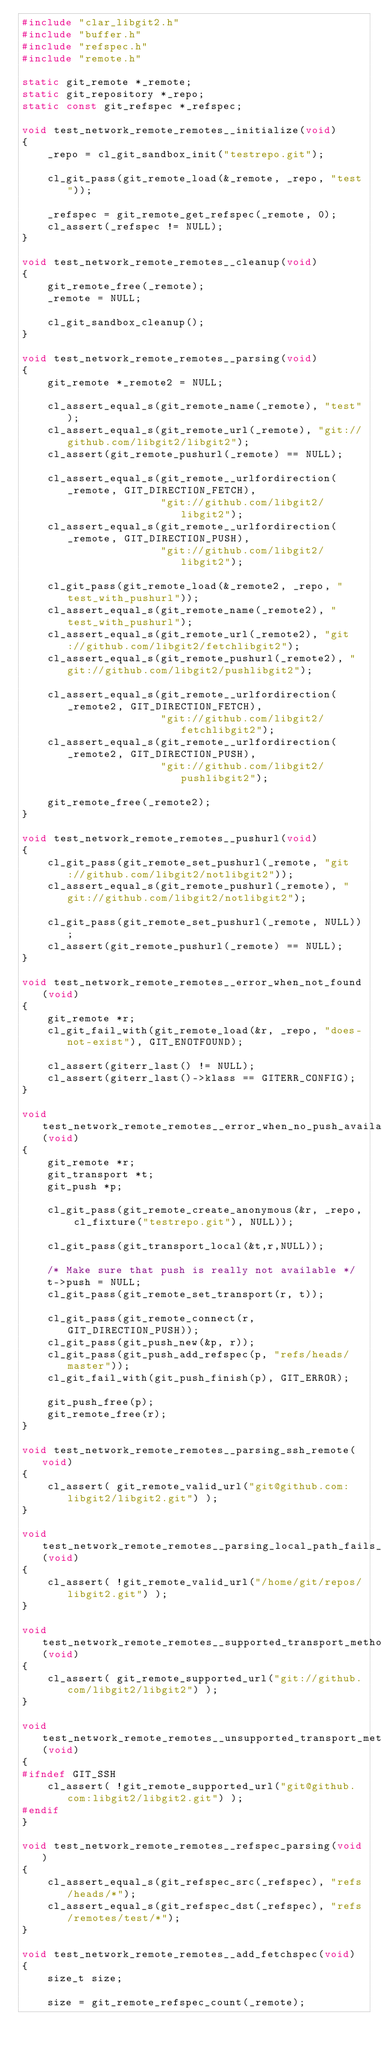Convert code to text. <code><loc_0><loc_0><loc_500><loc_500><_C_>#include "clar_libgit2.h"
#include "buffer.h"
#include "refspec.h"
#include "remote.h"

static git_remote *_remote;
static git_repository *_repo;
static const git_refspec *_refspec;

void test_network_remote_remotes__initialize(void)
{
	_repo = cl_git_sandbox_init("testrepo.git");

	cl_git_pass(git_remote_load(&_remote, _repo, "test"));

	_refspec = git_remote_get_refspec(_remote, 0);
	cl_assert(_refspec != NULL);
}

void test_network_remote_remotes__cleanup(void)
{
	git_remote_free(_remote);
	_remote = NULL;

	cl_git_sandbox_cleanup();
}

void test_network_remote_remotes__parsing(void)
{
	git_remote *_remote2 = NULL;

	cl_assert_equal_s(git_remote_name(_remote), "test");
	cl_assert_equal_s(git_remote_url(_remote), "git://github.com/libgit2/libgit2");
	cl_assert(git_remote_pushurl(_remote) == NULL);

	cl_assert_equal_s(git_remote__urlfordirection(_remote, GIT_DIRECTION_FETCH),
					  "git://github.com/libgit2/libgit2");
	cl_assert_equal_s(git_remote__urlfordirection(_remote, GIT_DIRECTION_PUSH),
					  "git://github.com/libgit2/libgit2");

	cl_git_pass(git_remote_load(&_remote2, _repo, "test_with_pushurl"));
	cl_assert_equal_s(git_remote_name(_remote2), "test_with_pushurl");
	cl_assert_equal_s(git_remote_url(_remote2), "git://github.com/libgit2/fetchlibgit2");
	cl_assert_equal_s(git_remote_pushurl(_remote2), "git://github.com/libgit2/pushlibgit2");

	cl_assert_equal_s(git_remote__urlfordirection(_remote2, GIT_DIRECTION_FETCH),
					  "git://github.com/libgit2/fetchlibgit2");
	cl_assert_equal_s(git_remote__urlfordirection(_remote2, GIT_DIRECTION_PUSH),
					  "git://github.com/libgit2/pushlibgit2");

	git_remote_free(_remote2);
}

void test_network_remote_remotes__pushurl(void)
{
	cl_git_pass(git_remote_set_pushurl(_remote, "git://github.com/libgit2/notlibgit2"));
	cl_assert_equal_s(git_remote_pushurl(_remote), "git://github.com/libgit2/notlibgit2");

	cl_git_pass(git_remote_set_pushurl(_remote, NULL));
	cl_assert(git_remote_pushurl(_remote) == NULL);
}

void test_network_remote_remotes__error_when_not_found(void)
{
	git_remote *r;
	cl_git_fail_with(git_remote_load(&r, _repo, "does-not-exist"), GIT_ENOTFOUND);

	cl_assert(giterr_last() != NULL);
	cl_assert(giterr_last()->klass == GITERR_CONFIG);
}

void test_network_remote_remotes__error_when_no_push_available(void)
{
	git_remote *r;
	git_transport *t;
	git_push *p;

	cl_git_pass(git_remote_create_anonymous(&r, _repo, cl_fixture("testrepo.git"), NULL));

	cl_git_pass(git_transport_local(&t,r,NULL));

	/* Make sure that push is really not available */
	t->push = NULL;
	cl_git_pass(git_remote_set_transport(r, t));

	cl_git_pass(git_remote_connect(r, GIT_DIRECTION_PUSH));
	cl_git_pass(git_push_new(&p, r));
	cl_git_pass(git_push_add_refspec(p, "refs/heads/master"));
	cl_git_fail_with(git_push_finish(p), GIT_ERROR);

	git_push_free(p);
	git_remote_free(r);
}

void test_network_remote_remotes__parsing_ssh_remote(void)
{
	cl_assert( git_remote_valid_url("git@github.com:libgit2/libgit2.git") );
}

void test_network_remote_remotes__parsing_local_path_fails_if_path_not_found(void)
{
	cl_assert( !git_remote_valid_url("/home/git/repos/libgit2.git") );
}

void test_network_remote_remotes__supported_transport_methods_are_supported(void)
{
	cl_assert( git_remote_supported_url("git://github.com/libgit2/libgit2") );
}

void test_network_remote_remotes__unsupported_transport_methods_are_unsupported(void)
{
#ifndef GIT_SSH
	cl_assert( !git_remote_supported_url("git@github.com:libgit2/libgit2.git") );
#endif
}

void test_network_remote_remotes__refspec_parsing(void)
{
	cl_assert_equal_s(git_refspec_src(_refspec), "refs/heads/*");
	cl_assert_equal_s(git_refspec_dst(_refspec), "refs/remotes/test/*");
}

void test_network_remote_remotes__add_fetchspec(void)
{
	size_t size;

	size = git_remote_refspec_count(_remote);
</code> 